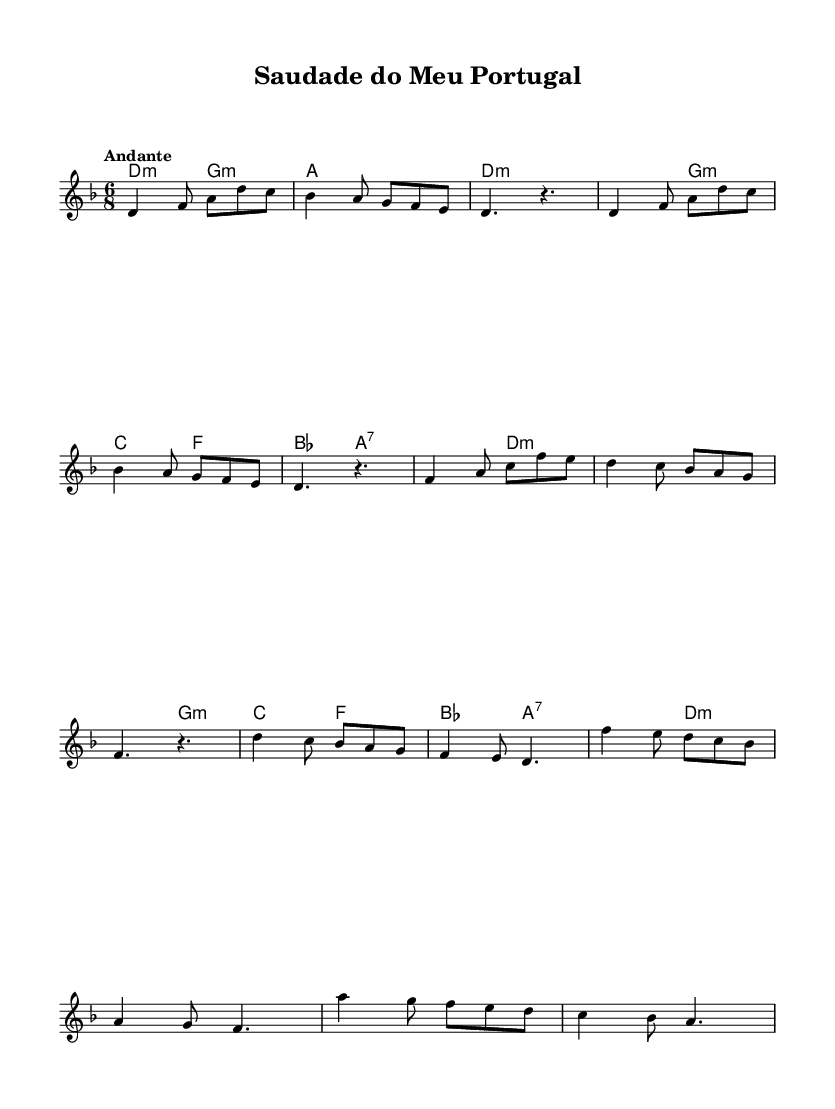What is the key signature of this music? The key signature is D minor, which is indicated by one flat (B♭) in the key signature at the beginning of the staff.
Answer: D minor What is the time signature of this music? The time signature is 6/8, which appears at the beginning of the sheet music and indicates a compound duple meter with six eighth notes per measure.
Answer: 6/8 What is the tempo marking of this piece? The tempo marking "Andante" suggests a moderately slow tempo, typical for a reflective and romantic piece. It is mentioned directly above the staff in the score.
Answer: Andante What is the first chord in the piece? The first chord in the music is D minor, which is represented at the start of the score with the chord symbol "d4.:m".
Answer: D minor How many measures are in the chorus section? The chorus section, as shown in the provided music, consists of three measures, indicated by the specific rhythm and notes outlined in that section.
Answer: 3 What kind of musical themes are suggested by the title "Saudade do Meu Portugal"? The title suggests themes of longing and nostalgia, specifically relating to homesickness associated with Portuguese culture, as indicated by the word "Saudade" which embodies a deep emotional state.
Answer: Longing and nostalgia What musical form does this piece primarily follow? The piece primarily follows a verse-chorus structure, as indicated by the organization of the melody and harmonies, alternating between verses and a chorus section.
Answer: Verse-chorus 